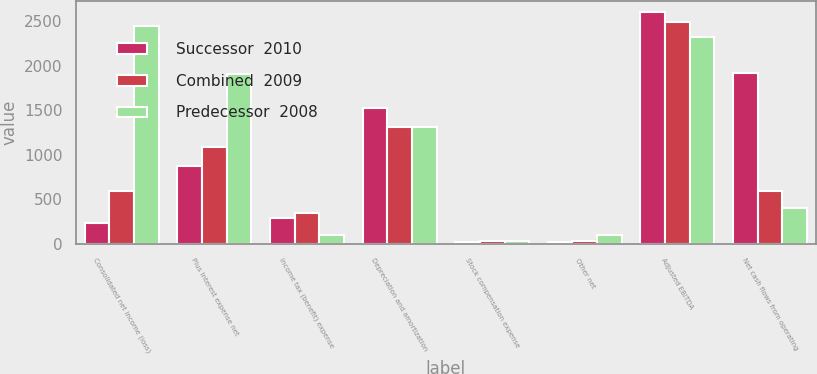<chart> <loc_0><loc_0><loc_500><loc_500><stacked_bar_chart><ecel><fcel>Consolidated net income (loss)<fcel>Plus Interest expense net<fcel>Income tax (benefit) expense<fcel>Depreciation and amortization<fcel>Stock compensation expense<fcel>Other net<fcel>Adjusted EBITDA<fcel>Net cash flows from operating<nl><fcel>Successor  2010<fcel>237<fcel>877<fcel>295<fcel>1524<fcel>26<fcel>23<fcel>2599<fcel>1911<nl><fcel>Combined  2009<fcel>594<fcel>1088<fcel>343<fcel>1316<fcel>27<fcel>29<fcel>2493<fcel>594<nl><fcel>Predecessor  2008<fcel>2447<fcel>1905<fcel>103<fcel>1310<fcel>33<fcel>104<fcel>2319<fcel>399<nl></chart> 